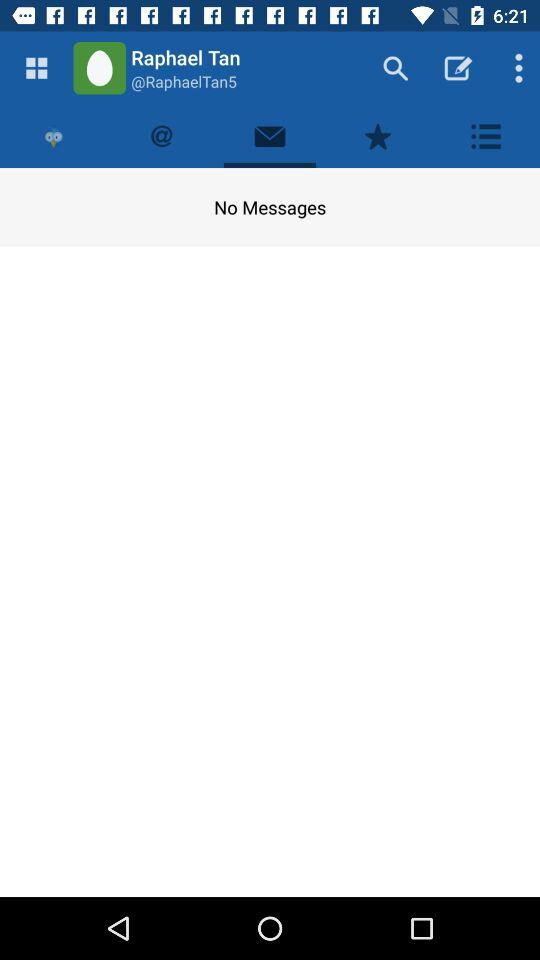What is the user name? The user name is Raphael Tan. 